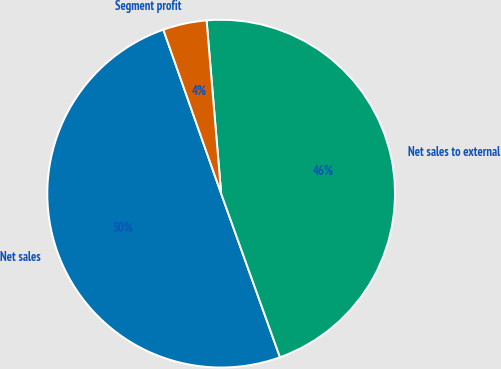<chart> <loc_0><loc_0><loc_500><loc_500><pie_chart><fcel>Net sales<fcel>Net sales to external<fcel>Segment profit<nl><fcel>50.1%<fcel>45.85%<fcel>4.06%<nl></chart> 